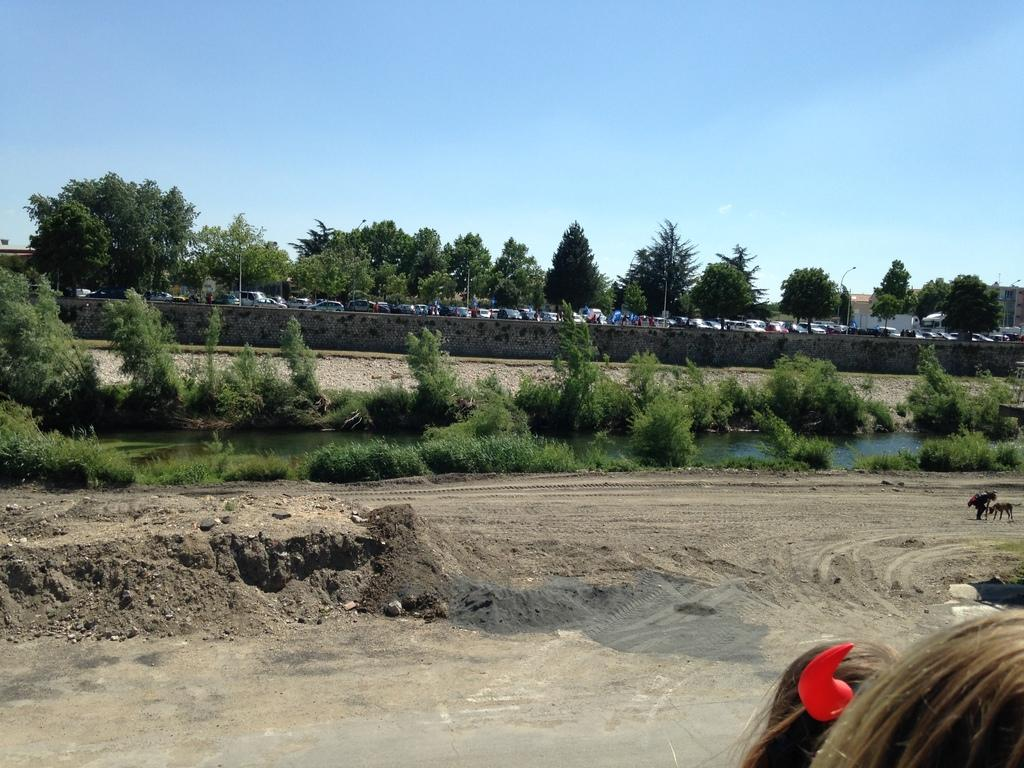Who or what can be seen in the image? There are people in the image. What type of natural elements are present in the image? There are trees in the image. What can be seen in the background of the image? In the background, there are animals, water, vehicles, and houses visible. How many knots are tied on the dad's shirt in the image? There is no dad or shirt with knots present in the image. What is the limit of the vehicles visible in the image? There is no limit mentioned for the vehicles visible in the image; we can only see that there are vehicles present in the background. 